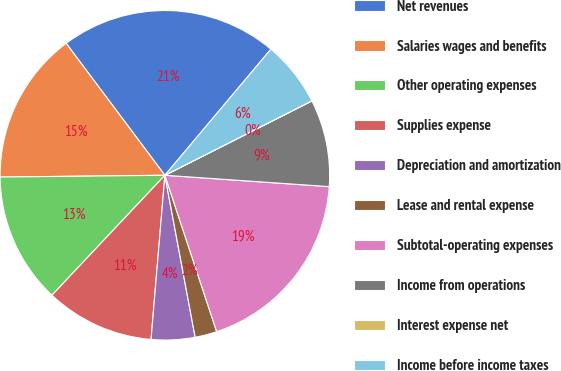Convert chart to OTSL. <chart><loc_0><loc_0><loc_500><loc_500><pie_chart><fcel>Net revenues<fcel>Salaries wages and benefits<fcel>Other operating expenses<fcel>Supplies expense<fcel>Depreciation and amortization<fcel>Lease and rental expense<fcel>Subtotal-operating expenses<fcel>Income from operations<fcel>Interest expense net<fcel>Income before income taxes<nl><fcel>21.35%<fcel>14.95%<fcel>12.81%<fcel>10.68%<fcel>4.28%<fcel>2.15%<fcel>18.81%<fcel>8.55%<fcel>0.01%<fcel>6.41%<nl></chart> 